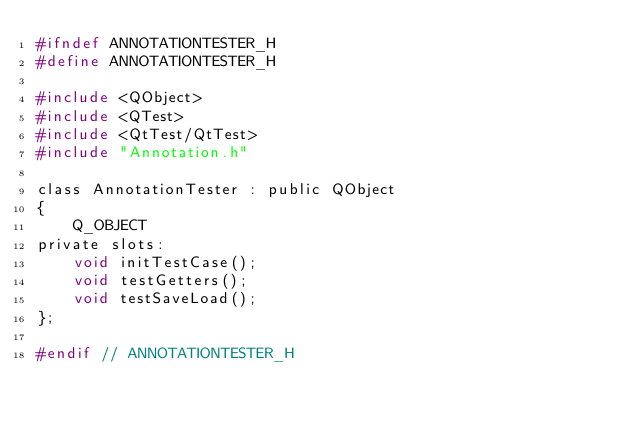<code> <loc_0><loc_0><loc_500><loc_500><_C_>#ifndef ANNOTATIONTESTER_H
#define ANNOTATIONTESTER_H

#include <QObject>
#include <QTest>
#include <QtTest/QtTest>
#include "Annotation.h"

class AnnotationTester : public QObject
{
    Q_OBJECT
private slots:
    void initTestCase();
    void testGetters();
    void testSaveLoad();
};

#endif // ANNOTATIONTESTER_H
</code> 